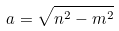<formula> <loc_0><loc_0><loc_500><loc_500>a = \sqrt { n ^ { 2 } - m ^ { 2 } }</formula> 